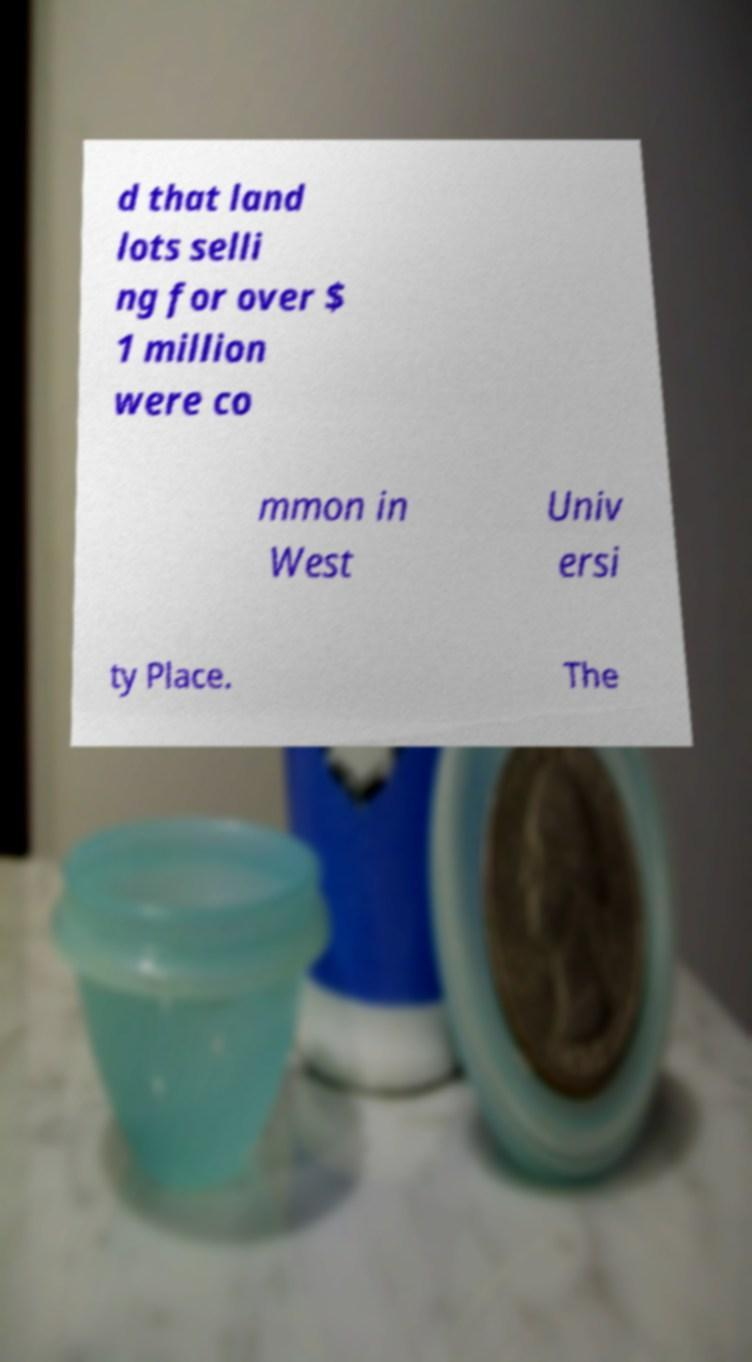What messages or text are displayed in this image? I need them in a readable, typed format. d that land lots selli ng for over $ 1 million were co mmon in West Univ ersi ty Place. The 